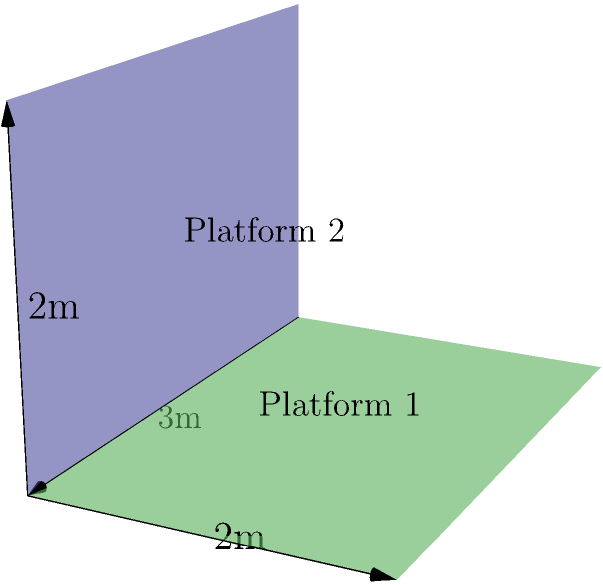In a Broadway musical set design, two rectangular stage platforms intersect at right angles. Platform 1 is horizontal and measures 3m by 2m, while Platform 2 is vertical and measures 3m by 2m. What is the angle between the normal vectors of these two platforms? To solve this problem, we need to follow these steps:

1) First, let's identify the normal vectors of each platform:
   - Platform 1 (horizontal): $\vec{n_1} = (0, 0, 1)$
   - Platform 2 (vertical): $\vec{n_2} = (0, 1, 0)$

2) The angle between two vectors can be calculated using the dot product formula:
   $$\cos \theta = \frac{\vec{n_1} \cdot \vec{n_2}}{|\vec{n_1}||\vec{n_2}|}$$

3) Calculate the dot product $\vec{n_1} \cdot \vec{n_2}$:
   $\vec{n_1} \cdot \vec{n_2} = (0)(0) + (0)(1) + (1)(0) = 0$

4) Calculate the magnitudes:
   $|\vec{n_1}| = \sqrt{0^2 + 0^2 + 1^2} = 1$
   $|\vec{n_2}| = \sqrt{0^2 + 1^2 + 0^2} = 1$

5) Substitute into the formula:
   $$\cos \theta = \frac{0}{(1)(1)} = 0$$

6) Solve for $\theta$:
   $$\theta = \arccos(0) = 90°$$

Therefore, the angle between the normal vectors of the two platforms is 90°.
Answer: 90° 